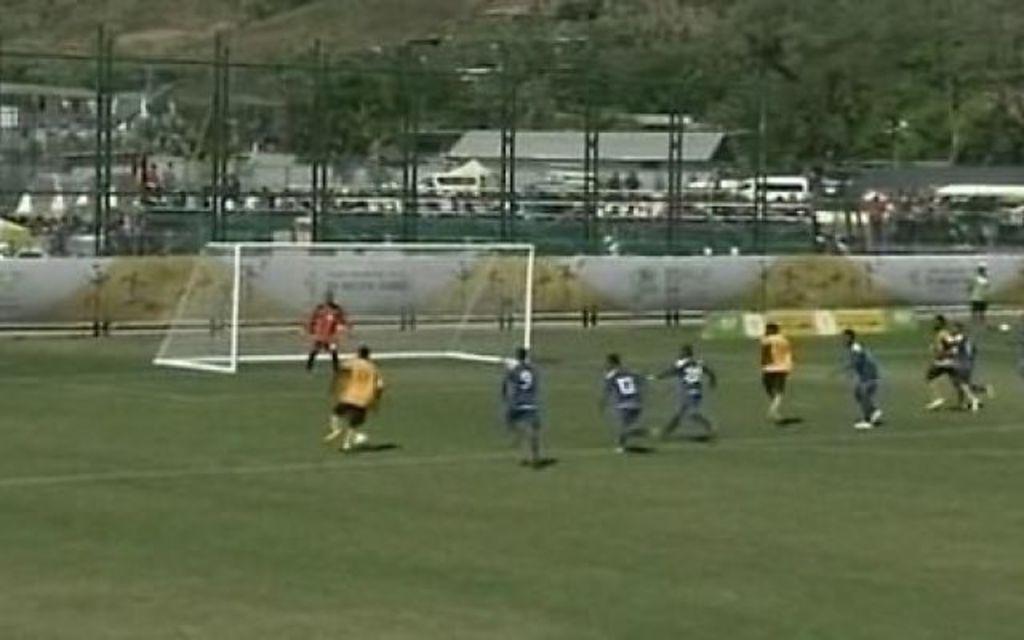Describe this image in one or two sentences. There are group of people running. I think they are playing the football game. This is a football goal post. I think this is a fence. These are the hoardings. In the background, I can see the buildings and trees. 